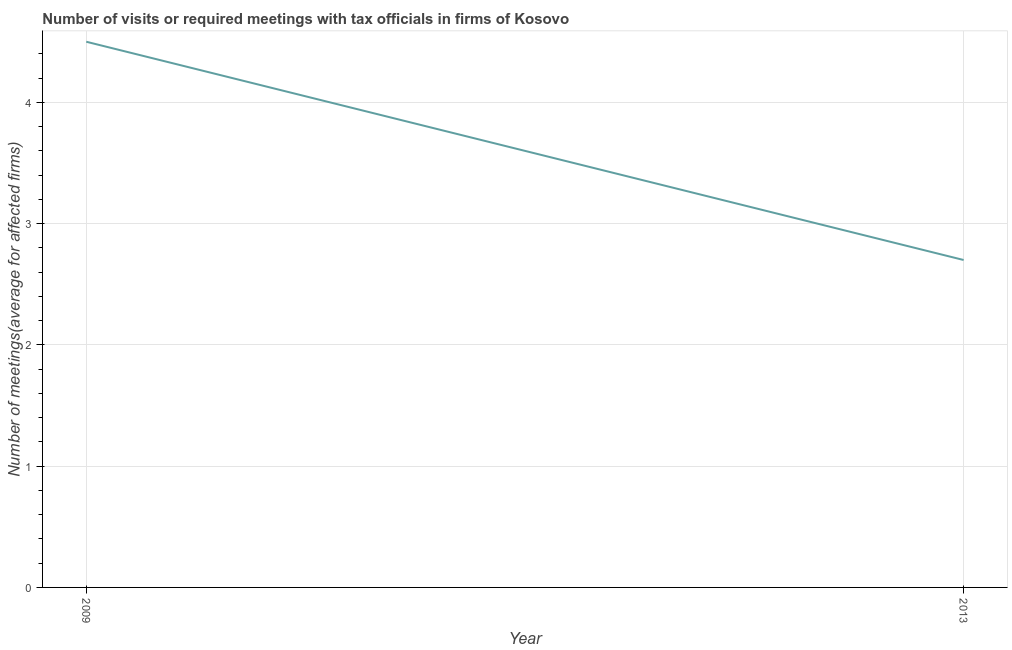What is the number of required meetings with tax officials in 2009?
Your answer should be very brief. 4.5. Across all years, what is the maximum number of required meetings with tax officials?
Give a very brief answer. 4.5. Across all years, what is the minimum number of required meetings with tax officials?
Make the answer very short. 2.7. In which year was the number of required meetings with tax officials minimum?
Keep it short and to the point. 2013. What is the difference between the number of required meetings with tax officials in 2009 and 2013?
Provide a short and direct response. 1.8. What is the median number of required meetings with tax officials?
Keep it short and to the point. 3.6. Do a majority of the years between 2013 and 2009 (inclusive) have number of required meetings with tax officials greater than 2.6 ?
Offer a very short reply. No. What is the ratio of the number of required meetings with tax officials in 2009 to that in 2013?
Offer a very short reply. 1.67. Does the number of required meetings with tax officials monotonically increase over the years?
Your answer should be very brief. No. What is the difference between two consecutive major ticks on the Y-axis?
Your response must be concise. 1. Does the graph contain any zero values?
Make the answer very short. No. What is the title of the graph?
Make the answer very short. Number of visits or required meetings with tax officials in firms of Kosovo. What is the label or title of the Y-axis?
Offer a terse response. Number of meetings(average for affected firms). What is the ratio of the Number of meetings(average for affected firms) in 2009 to that in 2013?
Offer a very short reply. 1.67. 